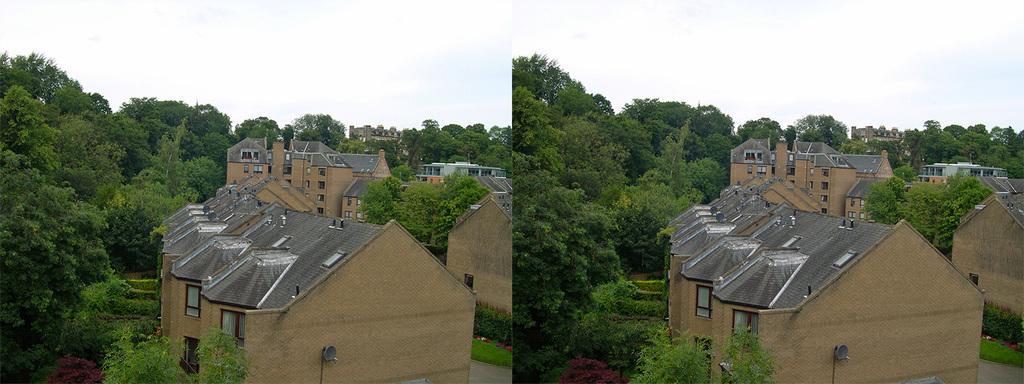Could you give a brief overview of what you see in this image? The image is about the collage of two pictures which are same in both. There is a buildings which are side by side and there in front of the buildings there are lot of trees in an area and the sky is clear in both the images. 